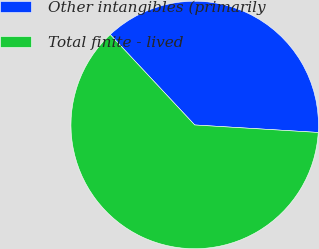<chart> <loc_0><loc_0><loc_500><loc_500><pie_chart><fcel>Other intangibles (primarily<fcel>Total finite - lived<nl><fcel>37.93%<fcel>62.07%<nl></chart> 